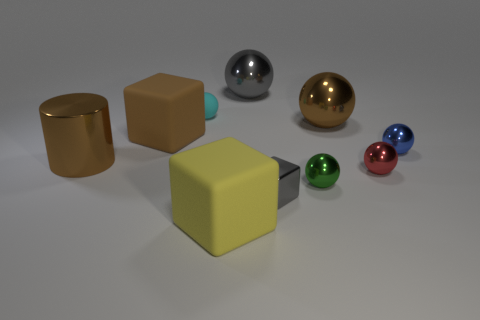There is a brown metal object right of the gray metallic ball; is it the same size as the small green object?
Provide a short and direct response. No. How many red shiny balls are on the left side of the sphere left of the metal ball behind the large brown metal ball?
Make the answer very short. 0. There is a ball that is both right of the small gray metal object and behind the brown cube; what size is it?
Your response must be concise. Large. How many other things are there of the same shape as the brown matte object?
Ensure brevity in your answer.  2. There is a tiny matte object; what number of big shiny balls are behind it?
Provide a short and direct response. 1. Is the number of green shiny objects that are to the left of the large brown rubber cube less than the number of gray spheres that are left of the small cyan ball?
Your response must be concise. No. There is a matte object in front of the big matte block behind the large object that is in front of the cylinder; what shape is it?
Ensure brevity in your answer.  Cube. The big object that is to the right of the yellow object and left of the small green metallic ball has what shape?
Your answer should be compact. Sphere. Are there any large blue balls that have the same material as the green object?
Provide a short and direct response. No. There is a shiny thing that is the same color as the small metallic block; what size is it?
Your answer should be very brief. Large. 